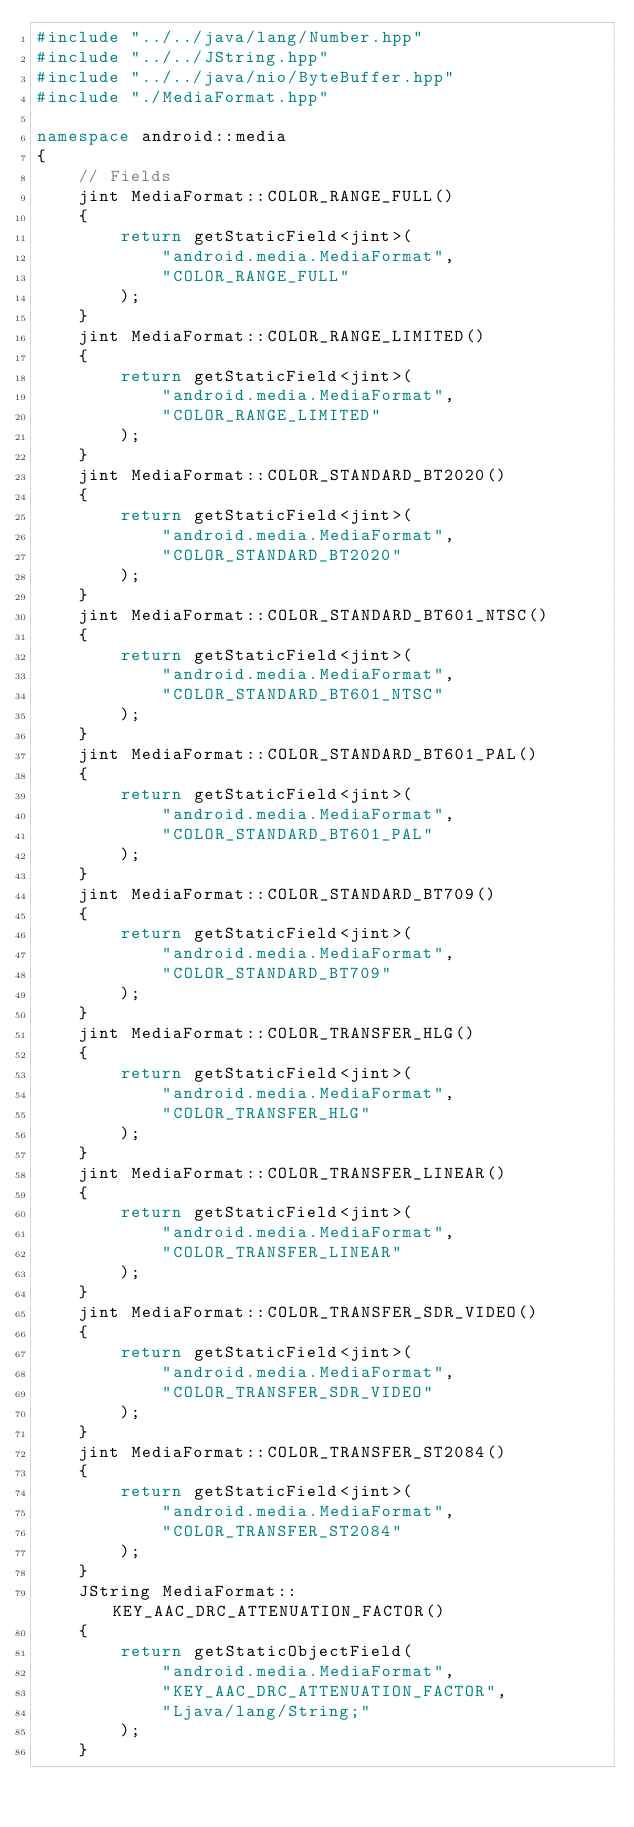<code> <loc_0><loc_0><loc_500><loc_500><_C++_>#include "../../java/lang/Number.hpp"
#include "../../JString.hpp"
#include "../../java/nio/ByteBuffer.hpp"
#include "./MediaFormat.hpp"

namespace android::media
{
	// Fields
	jint MediaFormat::COLOR_RANGE_FULL()
	{
		return getStaticField<jint>(
			"android.media.MediaFormat",
			"COLOR_RANGE_FULL"
		);
	}
	jint MediaFormat::COLOR_RANGE_LIMITED()
	{
		return getStaticField<jint>(
			"android.media.MediaFormat",
			"COLOR_RANGE_LIMITED"
		);
	}
	jint MediaFormat::COLOR_STANDARD_BT2020()
	{
		return getStaticField<jint>(
			"android.media.MediaFormat",
			"COLOR_STANDARD_BT2020"
		);
	}
	jint MediaFormat::COLOR_STANDARD_BT601_NTSC()
	{
		return getStaticField<jint>(
			"android.media.MediaFormat",
			"COLOR_STANDARD_BT601_NTSC"
		);
	}
	jint MediaFormat::COLOR_STANDARD_BT601_PAL()
	{
		return getStaticField<jint>(
			"android.media.MediaFormat",
			"COLOR_STANDARD_BT601_PAL"
		);
	}
	jint MediaFormat::COLOR_STANDARD_BT709()
	{
		return getStaticField<jint>(
			"android.media.MediaFormat",
			"COLOR_STANDARD_BT709"
		);
	}
	jint MediaFormat::COLOR_TRANSFER_HLG()
	{
		return getStaticField<jint>(
			"android.media.MediaFormat",
			"COLOR_TRANSFER_HLG"
		);
	}
	jint MediaFormat::COLOR_TRANSFER_LINEAR()
	{
		return getStaticField<jint>(
			"android.media.MediaFormat",
			"COLOR_TRANSFER_LINEAR"
		);
	}
	jint MediaFormat::COLOR_TRANSFER_SDR_VIDEO()
	{
		return getStaticField<jint>(
			"android.media.MediaFormat",
			"COLOR_TRANSFER_SDR_VIDEO"
		);
	}
	jint MediaFormat::COLOR_TRANSFER_ST2084()
	{
		return getStaticField<jint>(
			"android.media.MediaFormat",
			"COLOR_TRANSFER_ST2084"
		);
	}
	JString MediaFormat::KEY_AAC_DRC_ATTENUATION_FACTOR()
	{
		return getStaticObjectField(
			"android.media.MediaFormat",
			"KEY_AAC_DRC_ATTENUATION_FACTOR",
			"Ljava/lang/String;"
		);
	}</code> 